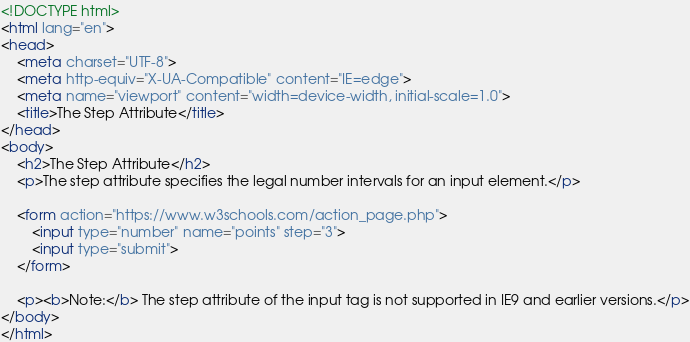Convert code to text. <code><loc_0><loc_0><loc_500><loc_500><_HTML_><!DOCTYPE html>
<html lang="en">
<head>
    <meta charset="UTF-8">
    <meta http-equiv="X-UA-Compatible" content="IE=edge">
    <meta name="viewport" content="width=device-width, initial-scale=1.0">
    <title>The Step Attribute</title>
</head>
<body>
    <h2>The Step Attribute</h2>
    <p>The step attribute specifies the legal number intervals for an input element.</p>

    <form action="https://www.w3schools.com/action_page.php">
        <input type="number" name="points" step="3">
        <input type="submit">
    </form>

    <p><b>Note:</b> The step attribute of the input tag is not supported in IE9 and earlier versions.</p>
</body>
</html></code> 